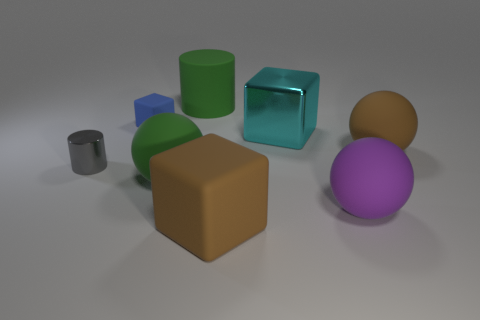There is a rubber ball behind the small metallic cylinder; what size is it?
Provide a succinct answer. Large. Are there fewer cyan blocks that are behind the tiny rubber cube than small rubber cubes that are on the right side of the rubber cylinder?
Ensure brevity in your answer.  No. What color is the big cylinder?
Give a very brief answer. Green. Are there any other tiny shiny cylinders that have the same color as the tiny cylinder?
Ensure brevity in your answer.  No. What shape is the brown object that is in front of the brown rubber thing that is to the right of the big brown matte thing that is in front of the tiny shiny cylinder?
Give a very brief answer. Cube. What material is the green object in front of the large cylinder?
Provide a succinct answer. Rubber. There is a metallic object to the right of the block to the left of the brown thing in front of the large brown ball; how big is it?
Offer a very short reply. Large. There is a blue thing; is it the same size as the green rubber thing that is in front of the brown matte ball?
Provide a short and direct response. No. What is the color of the cylinder that is on the right side of the tiny blue rubber object?
Ensure brevity in your answer.  Green. There is a large thing that is the same color as the rubber cylinder; what shape is it?
Offer a terse response. Sphere. 